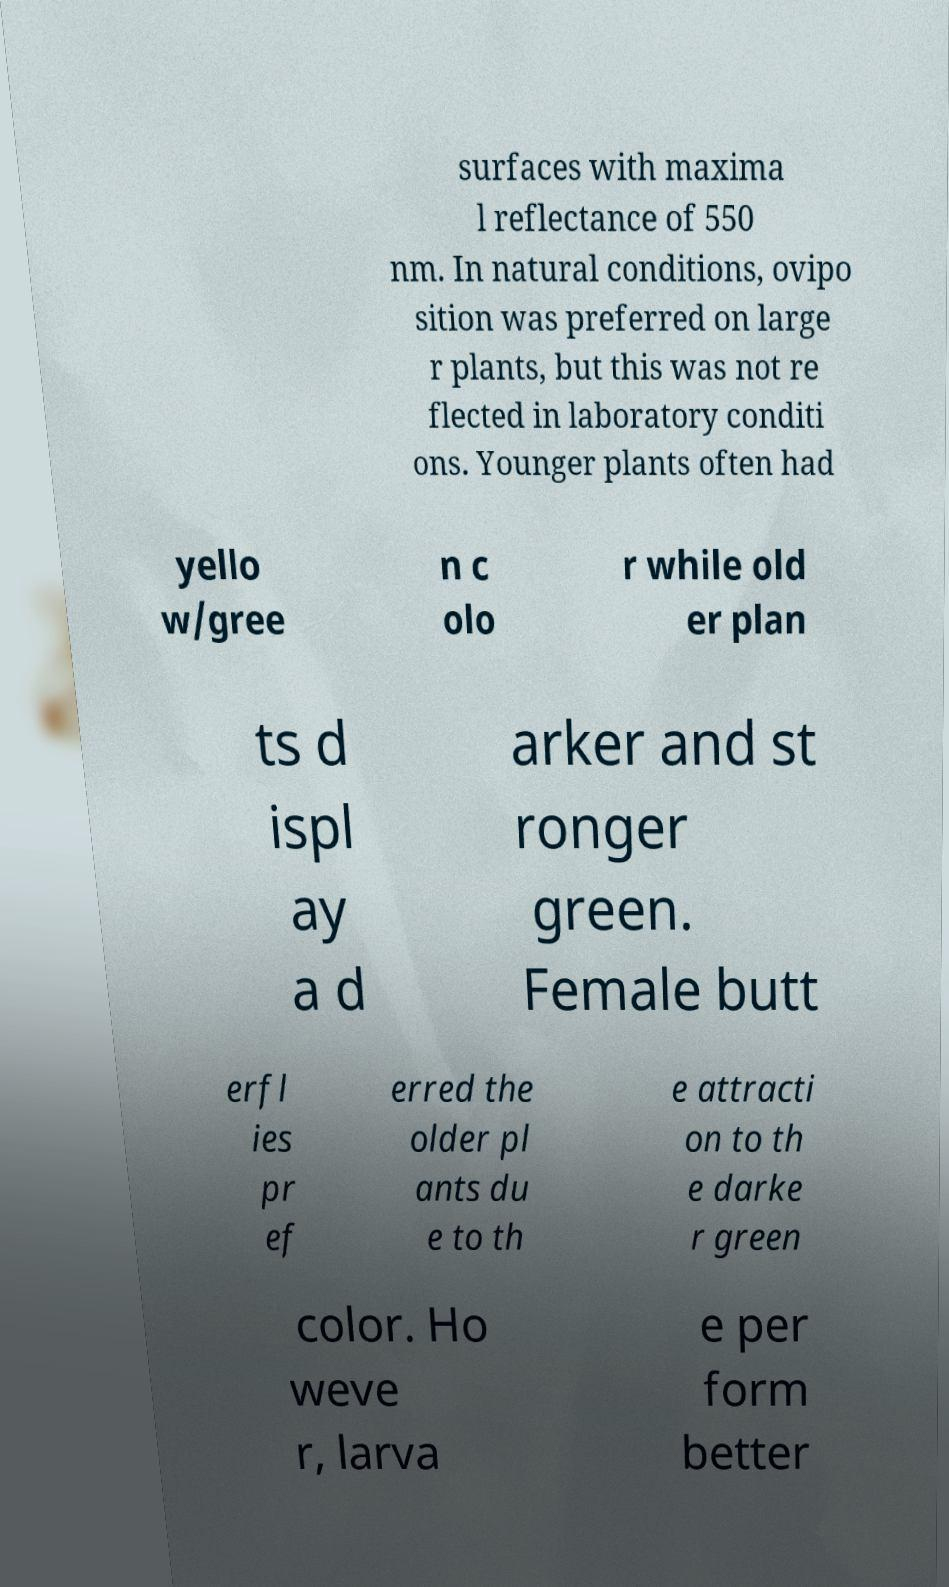Please read and relay the text visible in this image. What does it say? surfaces with maxima l reflectance of 550 nm. In natural conditions, ovipo sition was preferred on large r plants, but this was not re flected in laboratory conditi ons. Younger plants often had yello w/gree n c olo r while old er plan ts d ispl ay a d arker and st ronger green. Female butt erfl ies pr ef erred the older pl ants du e to th e attracti on to th e darke r green color. Ho weve r, larva e per form better 